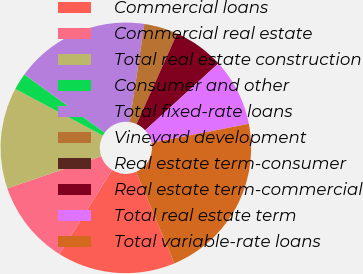Convert chart. <chart><loc_0><loc_0><loc_500><loc_500><pie_chart><fcel>Commercial loans<fcel>Commercial real estate<fcel>Total real estate construction<fcel>Consumer and other<fcel>Total fixed-rate loans<fcel>Vineyard development<fcel>Real estate term-consumer<fcel>Real estate term-commercial<fcel>Total real estate term<fcel>Total variable-rate loans<nl><fcel>15.22%<fcel>10.87%<fcel>13.04%<fcel>2.17%<fcel>17.39%<fcel>4.35%<fcel>0.0%<fcel>6.52%<fcel>8.7%<fcel>21.74%<nl></chart> 